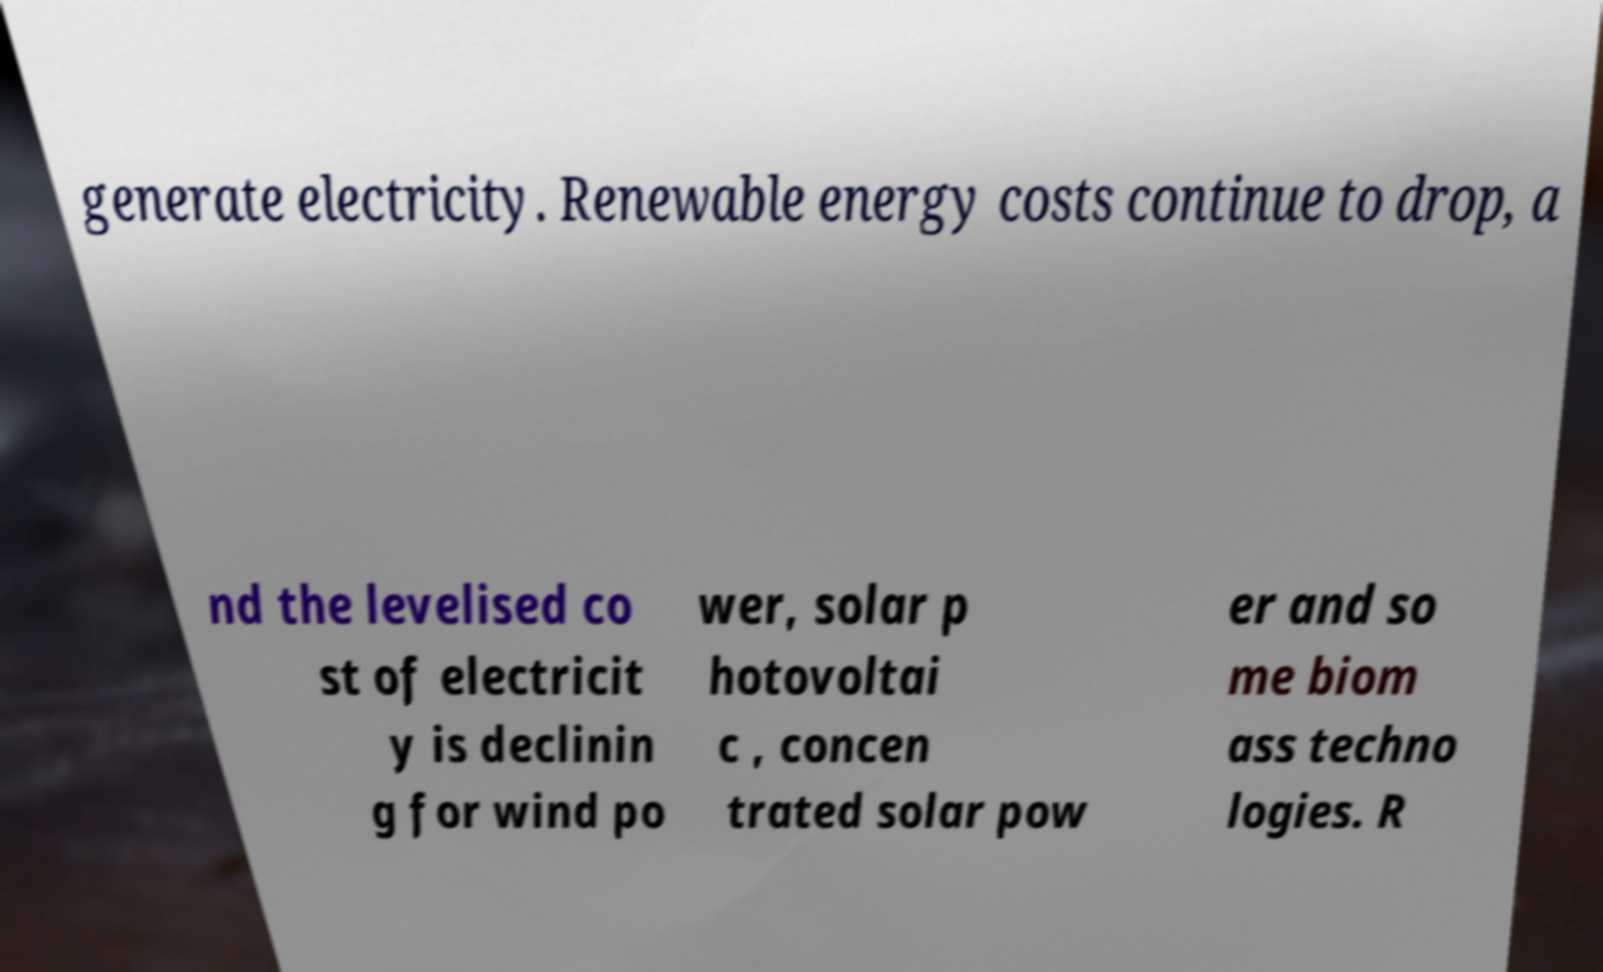Could you assist in decoding the text presented in this image and type it out clearly? generate electricity. Renewable energy costs continue to drop, a nd the levelised co st of electricit y is declinin g for wind po wer, solar p hotovoltai c , concen trated solar pow er and so me biom ass techno logies. R 